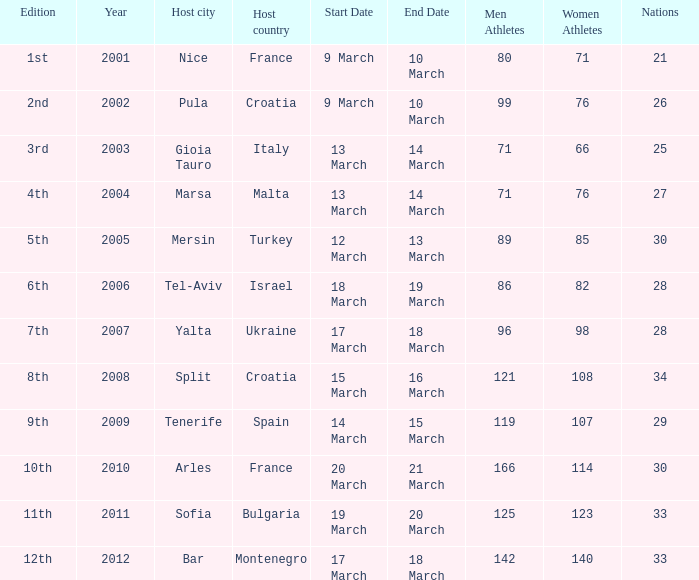What was the host city of the 8th edition in the the host country of Croatia? Split. 